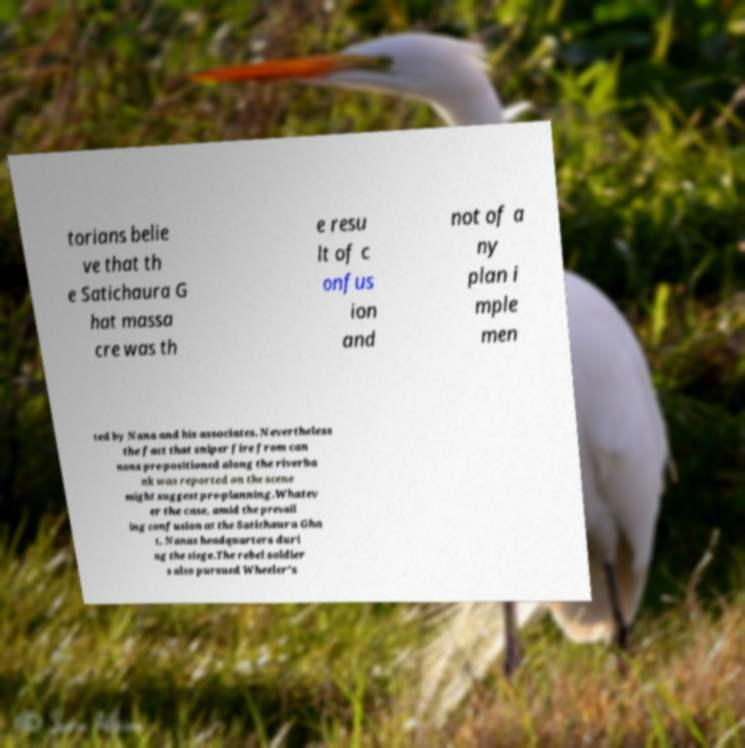Could you extract and type out the text from this image? torians belie ve that th e Satichaura G hat massa cre was th e resu lt of c onfus ion and not of a ny plan i mple men ted by Nana and his associates. Nevertheless the fact that sniper fire from can nons pre-positioned along the riverba nk was reported on the scene might suggest pre-planning.Whatev er the case, amid the prevail ing confusion at the Satichaura Gha t, Nanas headquarters duri ng the siege.The rebel soldier s also pursued Wheeler's 